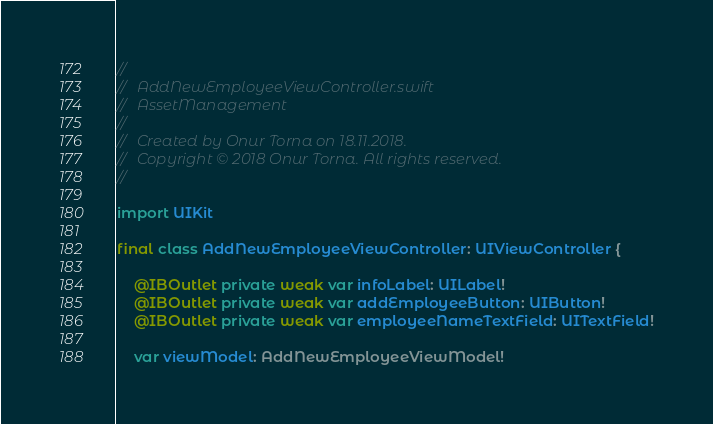<code> <loc_0><loc_0><loc_500><loc_500><_Swift_>//
//  AddNewEmployeeViewController.swift
//  AssetManagement
//
//  Created by Onur Torna on 18.11.2018.
//  Copyright © 2018 Onur Torna. All rights reserved.
//

import UIKit

final class AddNewEmployeeViewController: UIViewController {

    @IBOutlet private weak var infoLabel: UILabel!
    @IBOutlet private weak var addEmployeeButton: UIButton!
    @IBOutlet private weak var employeeNameTextField: UITextField!

    var viewModel: AddNewEmployeeViewModel!
</code> 